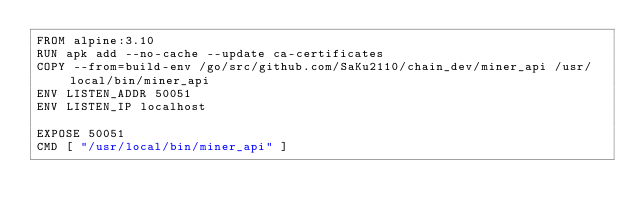Convert code to text. <code><loc_0><loc_0><loc_500><loc_500><_Dockerfile_>FROM alpine:3.10
RUN apk add --no-cache --update ca-certificates
COPY --from=build-env /go/src/github.com/SaKu2110/chain_dev/miner_api /usr/local/bin/miner_api
ENV LISTEN_ADDR 50051
ENV LISTEN_IP localhost

EXPOSE 50051
CMD [ "/usr/local/bin/miner_api" ]</code> 